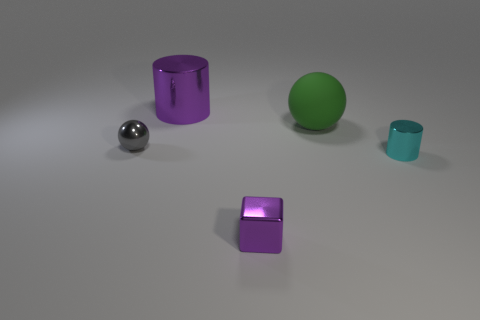Is there any other thing that has the same material as the big ball?
Your answer should be compact. No. What is the material of the tiny sphere?
Provide a short and direct response. Metal. There is a cylinder that is to the right of the cube; what is its material?
Provide a succinct answer. Metal. Is there anything else of the same color as the matte sphere?
Provide a short and direct response. No. What size is the purple cylinder that is the same material as the cyan object?
Give a very brief answer. Large. How many small things are cubes or green shiny cylinders?
Offer a very short reply. 1. What size is the purple thing that is in front of the tiny cyan cylinder that is on the right side of the purple metal thing that is in front of the big metallic object?
Your answer should be very brief. Small. What number of green matte spheres have the same size as the gray thing?
Provide a short and direct response. 0. How many objects are big yellow shiny cubes or tiny objects to the right of the green rubber sphere?
Keep it short and to the point. 1. What is the shape of the large purple object?
Give a very brief answer. Cylinder. 